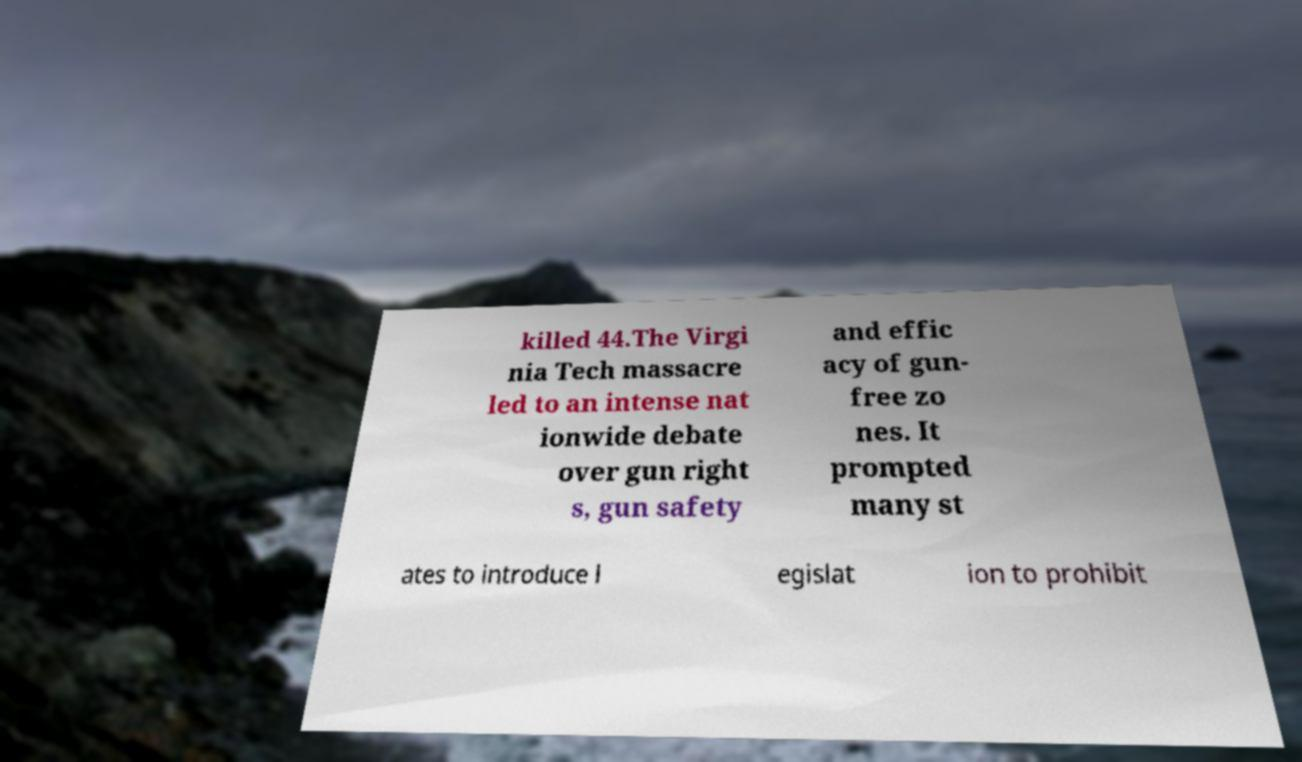Please read and relay the text visible in this image. What does it say? killed 44.The Virgi nia Tech massacre led to an intense nat ionwide debate over gun right s, gun safety and effic acy of gun- free zo nes. It prompted many st ates to introduce l egislat ion to prohibit 